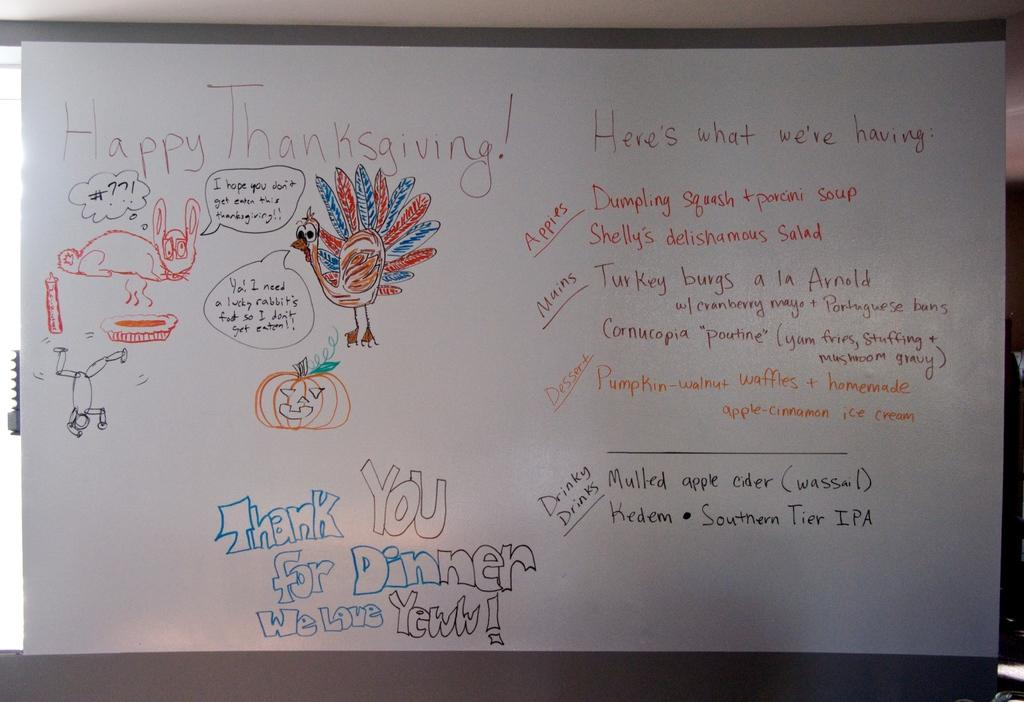<image>
Offer a succinct explanation of the picture presented. Happy Thanksgiving sign on a markerboard that says Happy Thanksgiving! Thank you for Dinner Welcome Yeww! 